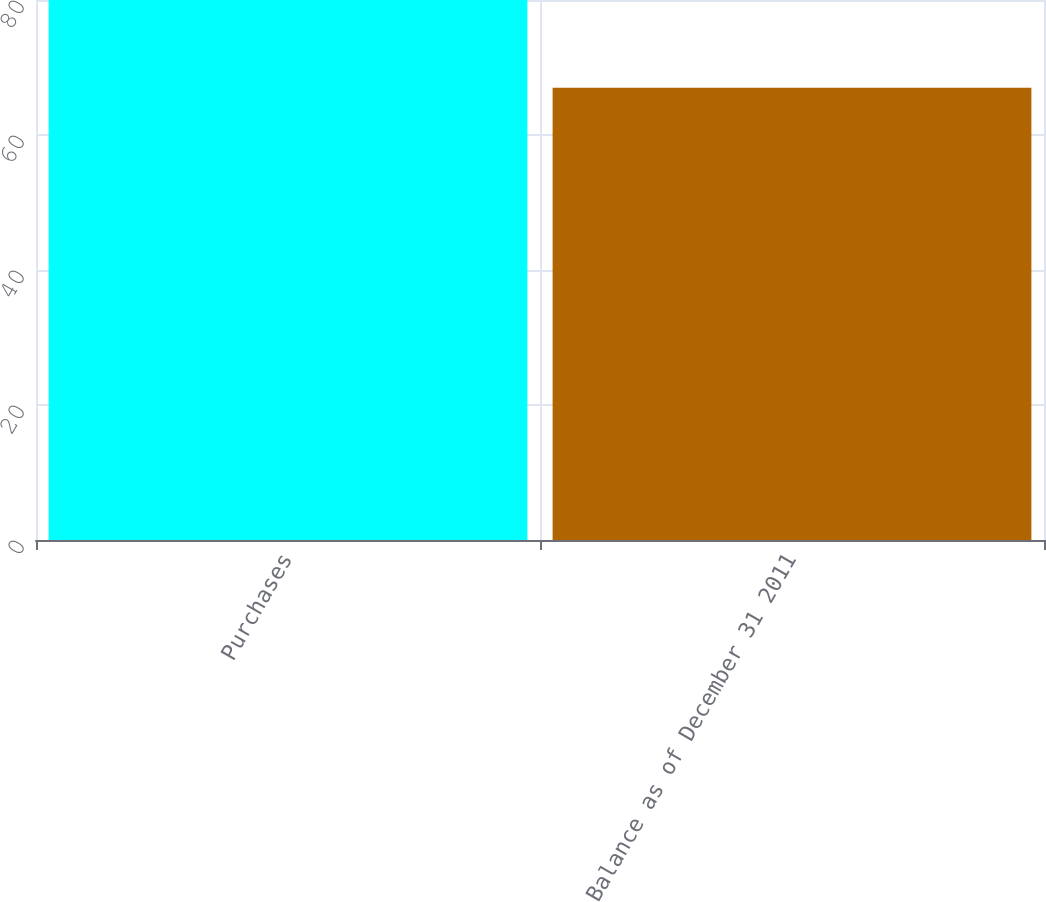<chart> <loc_0><loc_0><loc_500><loc_500><bar_chart><fcel>Purchases<fcel>Balance as of December 31 2011<nl><fcel>80<fcel>67<nl></chart> 